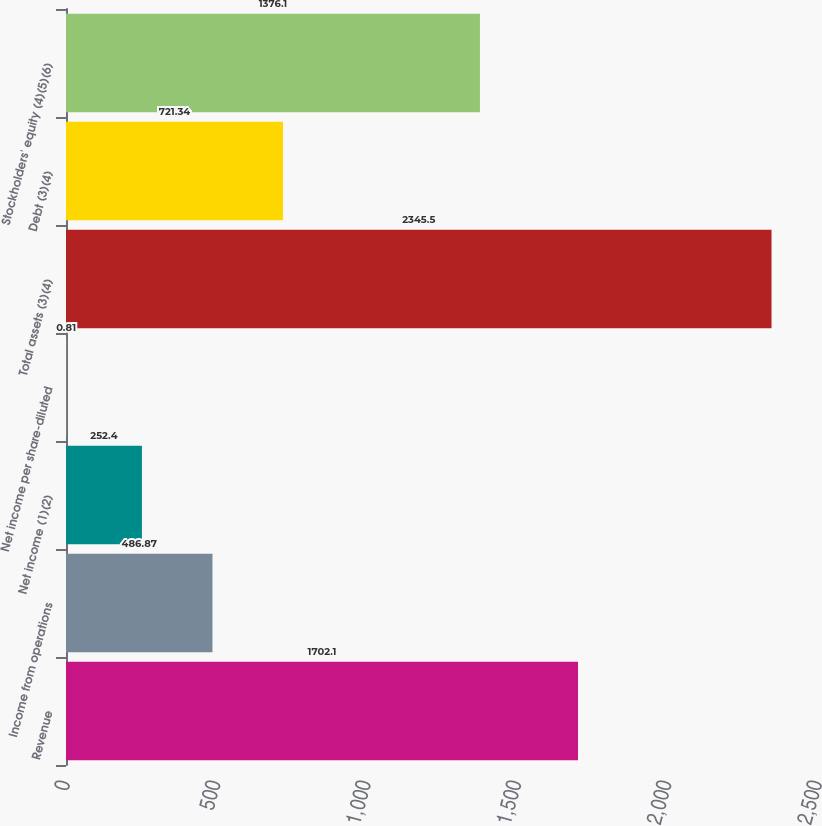Convert chart to OTSL. <chart><loc_0><loc_0><loc_500><loc_500><bar_chart><fcel>Revenue<fcel>Income from operations<fcel>Net income (1)(2)<fcel>Net income per share-diluted<fcel>Total assets (3)(4)<fcel>Debt (3)(4)<fcel>Stockholders' equity (4)(5)(6)<nl><fcel>1702.1<fcel>486.87<fcel>252.4<fcel>0.81<fcel>2345.5<fcel>721.34<fcel>1376.1<nl></chart> 